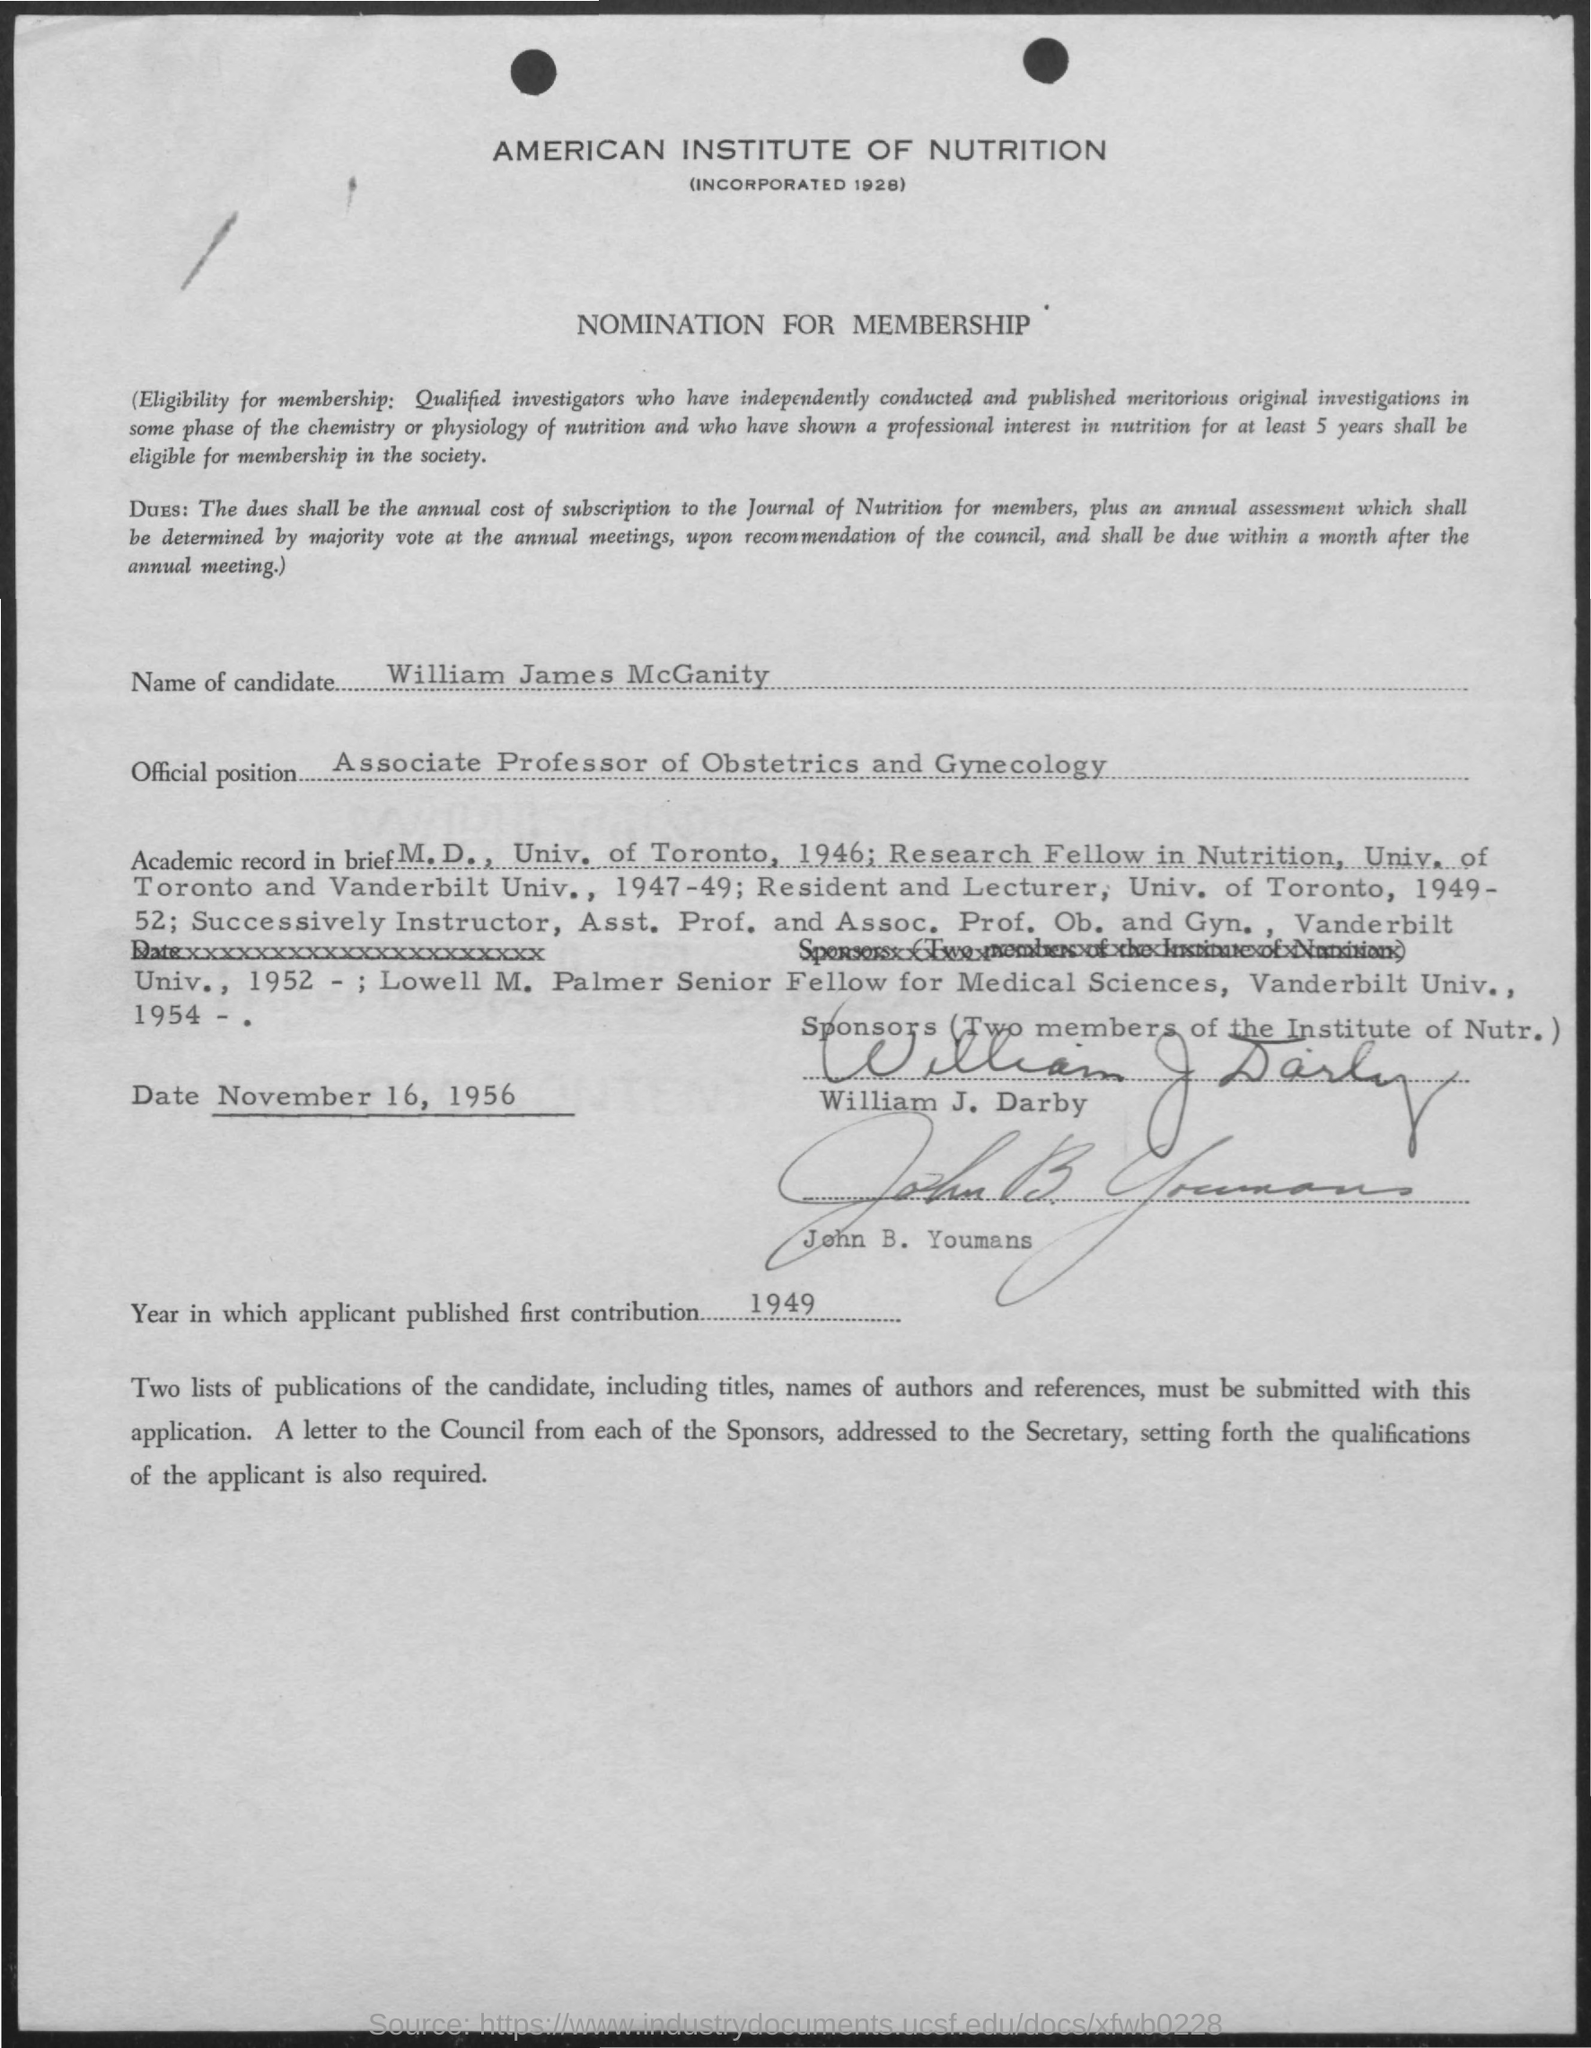What is the Name of the Candidate?
Keep it short and to the point. WILLIAM JAMES MCGANITY. What is the year in which the applicant published first contribution?
Ensure brevity in your answer.  1949. 